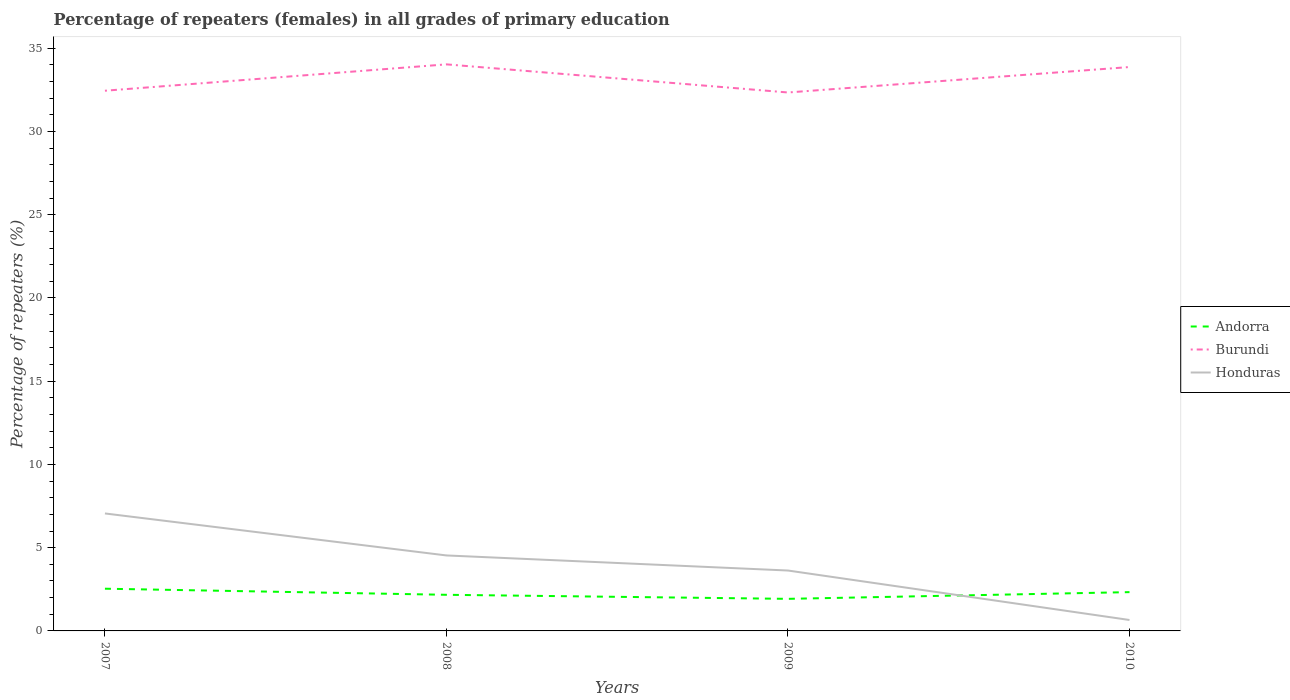Is the number of lines equal to the number of legend labels?
Your answer should be compact. Yes. Across all years, what is the maximum percentage of repeaters (females) in Andorra?
Your answer should be compact. 1.93. In which year was the percentage of repeaters (females) in Burundi maximum?
Provide a succinct answer. 2009. What is the total percentage of repeaters (females) in Burundi in the graph?
Your answer should be very brief. -1.53. What is the difference between the highest and the second highest percentage of repeaters (females) in Burundi?
Your answer should be very brief. 1.69. How many lines are there?
Your response must be concise. 3. What is the difference between two consecutive major ticks on the Y-axis?
Make the answer very short. 5. Are the values on the major ticks of Y-axis written in scientific E-notation?
Your response must be concise. No. Where does the legend appear in the graph?
Ensure brevity in your answer.  Center right. How are the legend labels stacked?
Your answer should be compact. Vertical. What is the title of the graph?
Provide a short and direct response. Percentage of repeaters (females) in all grades of primary education. Does "Bermuda" appear as one of the legend labels in the graph?
Make the answer very short. No. What is the label or title of the X-axis?
Provide a succinct answer. Years. What is the label or title of the Y-axis?
Ensure brevity in your answer.  Percentage of repeaters (%). What is the Percentage of repeaters (%) in Andorra in 2007?
Offer a terse response. 2.54. What is the Percentage of repeaters (%) in Burundi in 2007?
Offer a very short reply. 32.45. What is the Percentage of repeaters (%) of Honduras in 2007?
Give a very brief answer. 7.06. What is the Percentage of repeaters (%) in Andorra in 2008?
Your response must be concise. 2.17. What is the Percentage of repeaters (%) in Burundi in 2008?
Your response must be concise. 34.03. What is the Percentage of repeaters (%) in Honduras in 2008?
Keep it short and to the point. 4.53. What is the Percentage of repeaters (%) of Andorra in 2009?
Ensure brevity in your answer.  1.93. What is the Percentage of repeaters (%) in Burundi in 2009?
Offer a terse response. 32.34. What is the Percentage of repeaters (%) of Honduras in 2009?
Your answer should be compact. 3.63. What is the Percentage of repeaters (%) in Andorra in 2010?
Offer a terse response. 2.33. What is the Percentage of repeaters (%) in Burundi in 2010?
Provide a short and direct response. 33.87. What is the Percentage of repeaters (%) in Honduras in 2010?
Make the answer very short. 0.66. Across all years, what is the maximum Percentage of repeaters (%) of Andorra?
Provide a succinct answer. 2.54. Across all years, what is the maximum Percentage of repeaters (%) in Burundi?
Ensure brevity in your answer.  34.03. Across all years, what is the maximum Percentage of repeaters (%) in Honduras?
Provide a short and direct response. 7.06. Across all years, what is the minimum Percentage of repeaters (%) of Andorra?
Ensure brevity in your answer.  1.93. Across all years, what is the minimum Percentage of repeaters (%) of Burundi?
Keep it short and to the point. 32.34. Across all years, what is the minimum Percentage of repeaters (%) of Honduras?
Offer a very short reply. 0.66. What is the total Percentage of repeaters (%) of Andorra in the graph?
Your response must be concise. 8.96. What is the total Percentage of repeaters (%) of Burundi in the graph?
Offer a very short reply. 132.69. What is the total Percentage of repeaters (%) of Honduras in the graph?
Your answer should be compact. 15.87. What is the difference between the Percentage of repeaters (%) of Andorra in 2007 and that in 2008?
Your response must be concise. 0.37. What is the difference between the Percentage of repeaters (%) of Burundi in 2007 and that in 2008?
Your answer should be compact. -1.58. What is the difference between the Percentage of repeaters (%) of Honduras in 2007 and that in 2008?
Make the answer very short. 2.52. What is the difference between the Percentage of repeaters (%) of Andorra in 2007 and that in 2009?
Provide a short and direct response. 0.61. What is the difference between the Percentage of repeaters (%) of Burundi in 2007 and that in 2009?
Offer a terse response. 0.11. What is the difference between the Percentage of repeaters (%) in Honduras in 2007 and that in 2009?
Offer a terse response. 3.43. What is the difference between the Percentage of repeaters (%) of Andorra in 2007 and that in 2010?
Provide a short and direct response. 0.21. What is the difference between the Percentage of repeaters (%) of Burundi in 2007 and that in 2010?
Give a very brief answer. -1.42. What is the difference between the Percentage of repeaters (%) of Honduras in 2007 and that in 2010?
Offer a terse response. 6.4. What is the difference between the Percentage of repeaters (%) of Andorra in 2008 and that in 2009?
Your answer should be compact. 0.24. What is the difference between the Percentage of repeaters (%) in Burundi in 2008 and that in 2009?
Offer a very short reply. 1.69. What is the difference between the Percentage of repeaters (%) in Honduras in 2008 and that in 2009?
Offer a terse response. 0.91. What is the difference between the Percentage of repeaters (%) of Andorra in 2008 and that in 2010?
Offer a very short reply. -0.16. What is the difference between the Percentage of repeaters (%) of Burundi in 2008 and that in 2010?
Give a very brief answer. 0.16. What is the difference between the Percentage of repeaters (%) in Honduras in 2008 and that in 2010?
Offer a very short reply. 3.88. What is the difference between the Percentage of repeaters (%) of Andorra in 2009 and that in 2010?
Give a very brief answer. -0.4. What is the difference between the Percentage of repeaters (%) in Burundi in 2009 and that in 2010?
Provide a succinct answer. -1.53. What is the difference between the Percentage of repeaters (%) of Honduras in 2009 and that in 2010?
Your answer should be very brief. 2.97. What is the difference between the Percentage of repeaters (%) in Andorra in 2007 and the Percentage of repeaters (%) in Burundi in 2008?
Offer a terse response. -31.5. What is the difference between the Percentage of repeaters (%) in Andorra in 2007 and the Percentage of repeaters (%) in Honduras in 2008?
Your answer should be very brief. -2. What is the difference between the Percentage of repeaters (%) in Burundi in 2007 and the Percentage of repeaters (%) in Honduras in 2008?
Keep it short and to the point. 27.91. What is the difference between the Percentage of repeaters (%) of Andorra in 2007 and the Percentage of repeaters (%) of Burundi in 2009?
Ensure brevity in your answer.  -29.81. What is the difference between the Percentage of repeaters (%) of Andorra in 2007 and the Percentage of repeaters (%) of Honduras in 2009?
Provide a short and direct response. -1.09. What is the difference between the Percentage of repeaters (%) in Burundi in 2007 and the Percentage of repeaters (%) in Honduras in 2009?
Offer a terse response. 28.82. What is the difference between the Percentage of repeaters (%) in Andorra in 2007 and the Percentage of repeaters (%) in Burundi in 2010?
Provide a succinct answer. -31.33. What is the difference between the Percentage of repeaters (%) of Andorra in 2007 and the Percentage of repeaters (%) of Honduras in 2010?
Make the answer very short. 1.88. What is the difference between the Percentage of repeaters (%) of Burundi in 2007 and the Percentage of repeaters (%) of Honduras in 2010?
Offer a very short reply. 31.79. What is the difference between the Percentage of repeaters (%) of Andorra in 2008 and the Percentage of repeaters (%) of Burundi in 2009?
Ensure brevity in your answer.  -30.17. What is the difference between the Percentage of repeaters (%) in Andorra in 2008 and the Percentage of repeaters (%) in Honduras in 2009?
Your response must be concise. -1.46. What is the difference between the Percentage of repeaters (%) of Burundi in 2008 and the Percentage of repeaters (%) of Honduras in 2009?
Offer a very short reply. 30.4. What is the difference between the Percentage of repeaters (%) of Andorra in 2008 and the Percentage of repeaters (%) of Burundi in 2010?
Provide a short and direct response. -31.7. What is the difference between the Percentage of repeaters (%) in Andorra in 2008 and the Percentage of repeaters (%) in Honduras in 2010?
Your answer should be compact. 1.51. What is the difference between the Percentage of repeaters (%) of Burundi in 2008 and the Percentage of repeaters (%) of Honduras in 2010?
Ensure brevity in your answer.  33.37. What is the difference between the Percentage of repeaters (%) of Andorra in 2009 and the Percentage of repeaters (%) of Burundi in 2010?
Your answer should be very brief. -31.94. What is the difference between the Percentage of repeaters (%) in Andorra in 2009 and the Percentage of repeaters (%) in Honduras in 2010?
Give a very brief answer. 1.27. What is the difference between the Percentage of repeaters (%) in Burundi in 2009 and the Percentage of repeaters (%) in Honduras in 2010?
Make the answer very short. 31.69. What is the average Percentage of repeaters (%) of Andorra per year?
Provide a short and direct response. 2.24. What is the average Percentage of repeaters (%) in Burundi per year?
Make the answer very short. 33.17. What is the average Percentage of repeaters (%) in Honduras per year?
Keep it short and to the point. 3.97. In the year 2007, what is the difference between the Percentage of repeaters (%) in Andorra and Percentage of repeaters (%) in Burundi?
Your answer should be very brief. -29.91. In the year 2007, what is the difference between the Percentage of repeaters (%) in Andorra and Percentage of repeaters (%) in Honduras?
Provide a short and direct response. -4.52. In the year 2007, what is the difference between the Percentage of repeaters (%) of Burundi and Percentage of repeaters (%) of Honduras?
Provide a short and direct response. 25.39. In the year 2008, what is the difference between the Percentage of repeaters (%) in Andorra and Percentage of repeaters (%) in Burundi?
Keep it short and to the point. -31.86. In the year 2008, what is the difference between the Percentage of repeaters (%) of Andorra and Percentage of repeaters (%) of Honduras?
Keep it short and to the point. -2.36. In the year 2008, what is the difference between the Percentage of repeaters (%) of Burundi and Percentage of repeaters (%) of Honduras?
Ensure brevity in your answer.  29.5. In the year 2009, what is the difference between the Percentage of repeaters (%) in Andorra and Percentage of repeaters (%) in Burundi?
Give a very brief answer. -30.42. In the year 2009, what is the difference between the Percentage of repeaters (%) of Andorra and Percentage of repeaters (%) of Honduras?
Provide a succinct answer. -1.7. In the year 2009, what is the difference between the Percentage of repeaters (%) of Burundi and Percentage of repeaters (%) of Honduras?
Your response must be concise. 28.71. In the year 2010, what is the difference between the Percentage of repeaters (%) in Andorra and Percentage of repeaters (%) in Burundi?
Ensure brevity in your answer.  -31.54. In the year 2010, what is the difference between the Percentage of repeaters (%) in Andorra and Percentage of repeaters (%) in Honduras?
Provide a short and direct response. 1.67. In the year 2010, what is the difference between the Percentage of repeaters (%) in Burundi and Percentage of repeaters (%) in Honduras?
Make the answer very short. 33.21. What is the ratio of the Percentage of repeaters (%) in Andorra in 2007 to that in 2008?
Offer a very short reply. 1.17. What is the ratio of the Percentage of repeaters (%) in Burundi in 2007 to that in 2008?
Your answer should be very brief. 0.95. What is the ratio of the Percentage of repeaters (%) in Honduras in 2007 to that in 2008?
Provide a succinct answer. 1.56. What is the ratio of the Percentage of repeaters (%) in Andorra in 2007 to that in 2009?
Offer a very short reply. 1.32. What is the ratio of the Percentage of repeaters (%) in Honduras in 2007 to that in 2009?
Offer a terse response. 1.95. What is the ratio of the Percentage of repeaters (%) of Andorra in 2007 to that in 2010?
Provide a short and direct response. 1.09. What is the ratio of the Percentage of repeaters (%) in Burundi in 2007 to that in 2010?
Provide a short and direct response. 0.96. What is the ratio of the Percentage of repeaters (%) in Honduras in 2007 to that in 2010?
Give a very brief answer. 10.75. What is the ratio of the Percentage of repeaters (%) of Andorra in 2008 to that in 2009?
Give a very brief answer. 1.13. What is the ratio of the Percentage of repeaters (%) of Burundi in 2008 to that in 2009?
Give a very brief answer. 1.05. What is the ratio of the Percentage of repeaters (%) of Honduras in 2008 to that in 2009?
Offer a very short reply. 1.25. What is the ratio of the Percentage of repeaters (%) of Andorra in 2008 to that in 2010?
Provide a succinct answer. 0.93. What is the ratio of the Percentage of repeaters (%) in Burundi in 2008 to that in 2010?
Provide a short and direct response. 1. What is the ratio of the Percentage of repeaters (%) of Honduras in 2008 to that in 2010?
Provide a short and direct response. 6.91. What is the ratio of the Percentage of repeaters (%) of Andorra in 2009 to that in 2010?
Provide a succinct answer. 0.83. What is the ratio of the Percentage of repeaters (%) in Burundi in 2009 to that in 2010?
Provide a succinct answer. 0.95. What is the ratio of the Percentage of repeaters (%) in Honduras in 2009 to that in 2010?
Ensure brevity in your answer.  5.53. What is the difference between the highest and the second highest Percentage of repeaters (%) in Andorra?
Your response must be concise. 0.21. What is the difference between the highest and the second highest Percentage of repeaters (%) in Burundi?
Provide a succinct answer. 0.16. What is the difference between the highest and the second highest Percentage of repeaters (%) in Honduras?
Give a very brief answer. 2.52. What is the difference between the highest and the lowest Percentage of repeaters (%) of Andorra?
Keep it short and to the point. 0.61. What is the difference between the highest and the lowest Percentage of repeaters (%) in Burundi?
Keep it short and to the point. 1.69. What is the difference between the highest and the lowest Percentage of repeaters (%) of Honduras?
Your answer should be very brief. 6.4. 